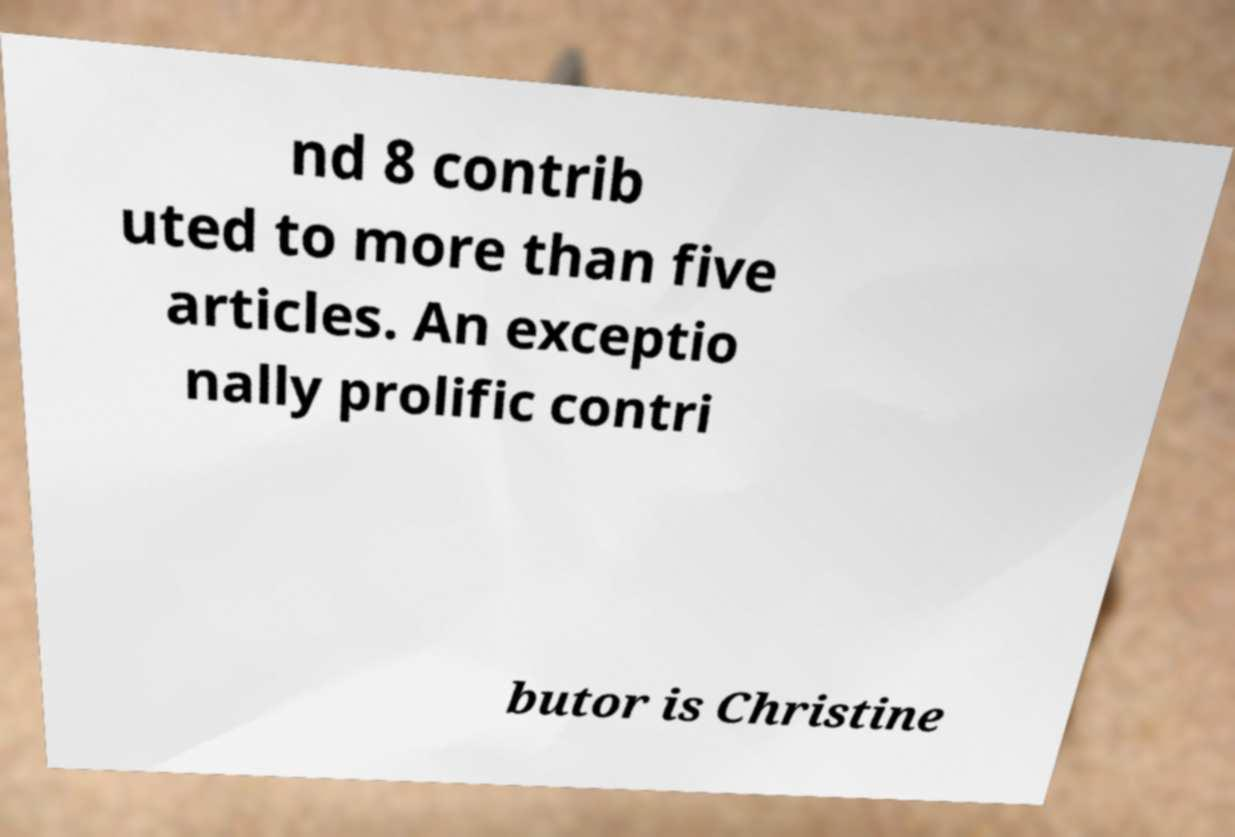Could you extract and type out the text from this image? nd 8 contrib uted to more than five articles. An exceptio nally prolific contri butor is Christine 